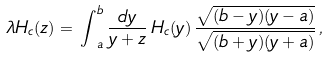<formula> <loc_0><loc_0><loc_500><loc_500>\lambda H _ { c } ( z ) = \, { \int } _ { a } ^ { b } \, \frac { d y } { y + z } \, H _ { c } ( y ) \, \frac { \sqrt { ( b - y ) ( y - a ) } } { \sqrt { ( b + y ) ( y + a ) } } \, ,</formula> 